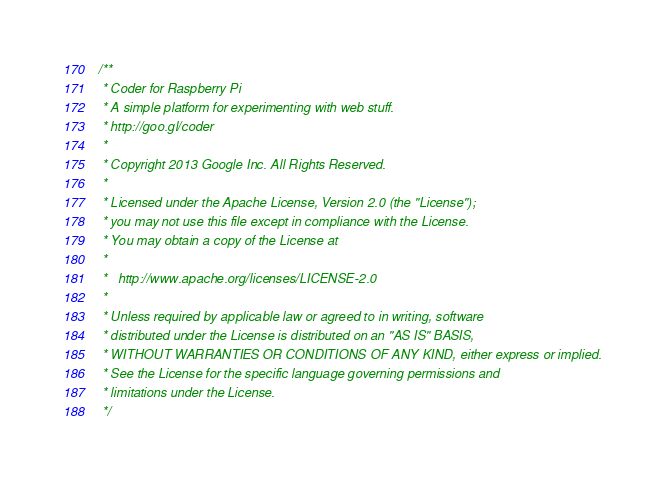Convert code to text. <code><loc_0><loc_0><loc_500><loc_500><_JavaScript_>/**
 * Coder for Raspberry Pi
 * A simple platform for experimenting with web stuff.
 * http://goo.gl/coder
 *
 * Copyright 2013 Google Inc. All Rights Reserved.
 *
 * Licensed under the Apache License, Version 2.0 (the "License");
 * you may not use this file except in compliance with the License.
 * You may obtain a copy of the License at
 *
 *   http://www.apache.org/licenses/LICENSE-2.0
 *
 * Unless required by applicable law or agreed to in writing, software
 * distributed under the License is distributed on an "AS IS" BASIS,
 * WITHOUT WARRANTIES OR CONDITIONS OF ANY KIND, either express or implied.
 * See the License for the specific language governing permissions and
 * limitations under the License.
 */

</code> 